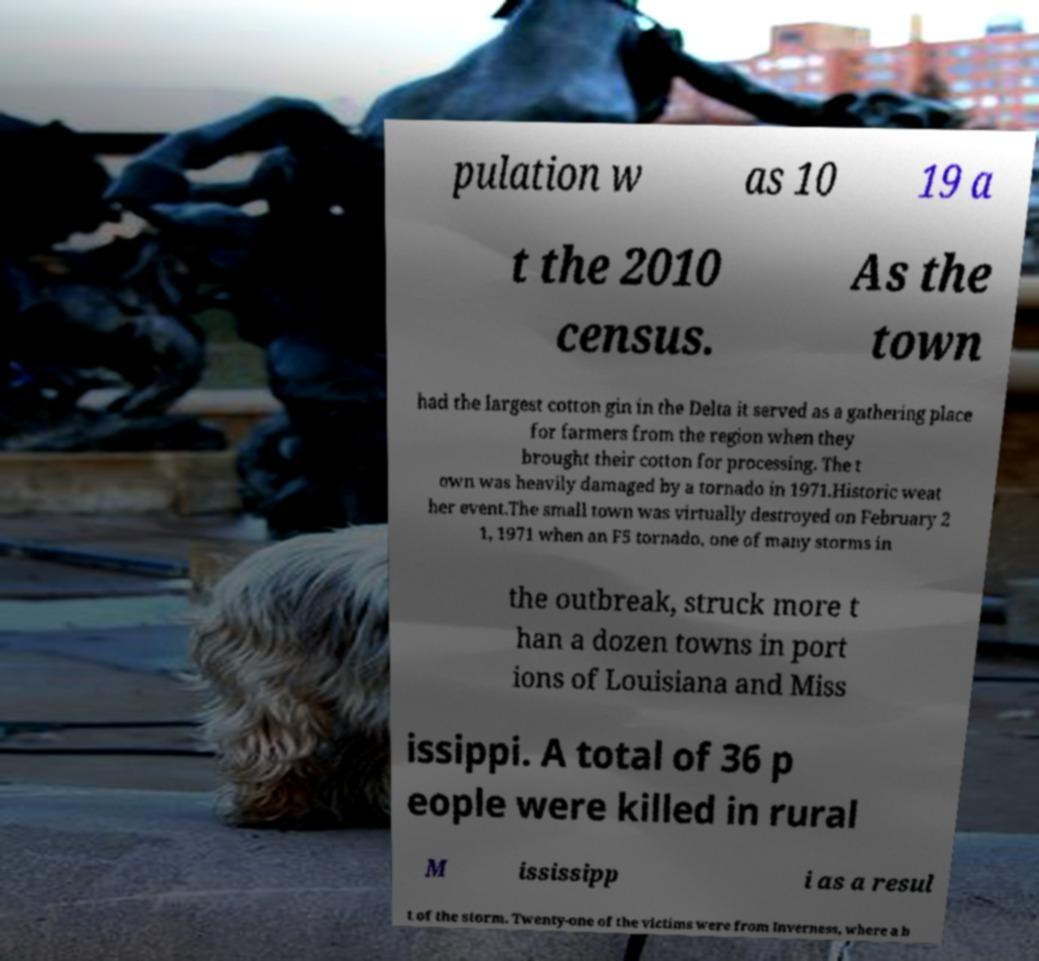Please read and relay the text visible in this image. What does it say? pulation w as 10 19 a t the 2010 census. As the town had the largest cotton gin in the Delta it served as a gathering place for farmers from the region when they brought their cotton for processing. The t own was heavily damaged by a tornado in 1971.Historic weat her event.The small town was virtually destroyed on February 2 1, 1971 when an F5 tornado, one of many storms in the outbreak, struck more t han a dozen towns in port ions of Louisiana and Miss issippi. A total of 36 p eople were killed in rural M ississipp i as a resul t of the storm. Twenty-one of the victims were from Inverness, where a b 